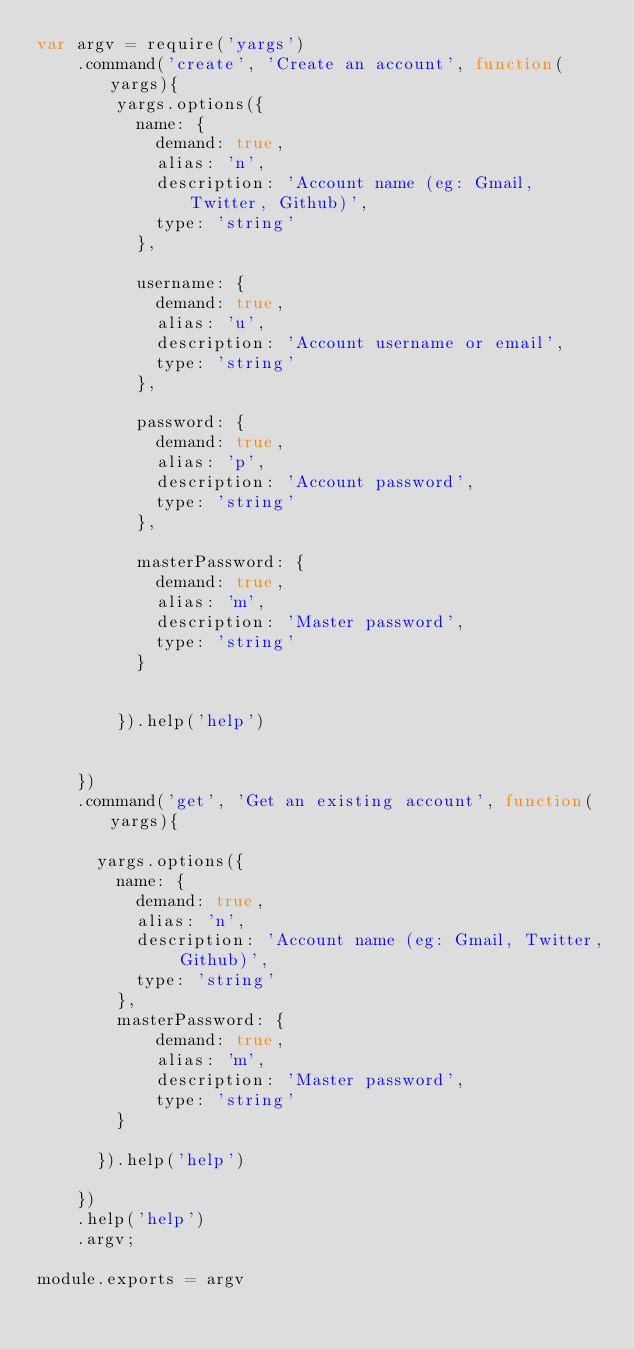<code> <loc_0><loc_0><loc_500><loc_500><_JavaScript_>var argv = require('yargs')
    .command('create', 'Create an account', function(yargs){
        yargs.options({
          name: {
            demand: true,
            alias: 'n',
            description: 'Account name (eg: Gmail, Twitter, Github)',
            type: 'string'
          },

          username: {
            demand: true,
            alias: 'u',
            description: 'Account username or email',
            type: 'string'
          },

          password: {
            demand: true,
            alias: 'p',
            description: 'Account password',
            type: 'string'
          },

          masterPassword: {
            demand: true,
            alias: 'm',
            description: 'Master password',
            type: 'string'
          }


        }).help('help')


    })
    .command('get', 'Get an existing account', function(yargs){

      yargs.options({
        name: {
          demand: true,
          alias: 'n',
          description: 'Account name (eg: Gmail, Twitter, Github)',
          type: 'string'
        },
        masterPassword: {
            demand: true,
            alias: 'm',
            description: 'Master password',
            type: 'string'
        }

      }).help('help')

    })
    .help('help')
    .argv;

module.exports = argv</code> 